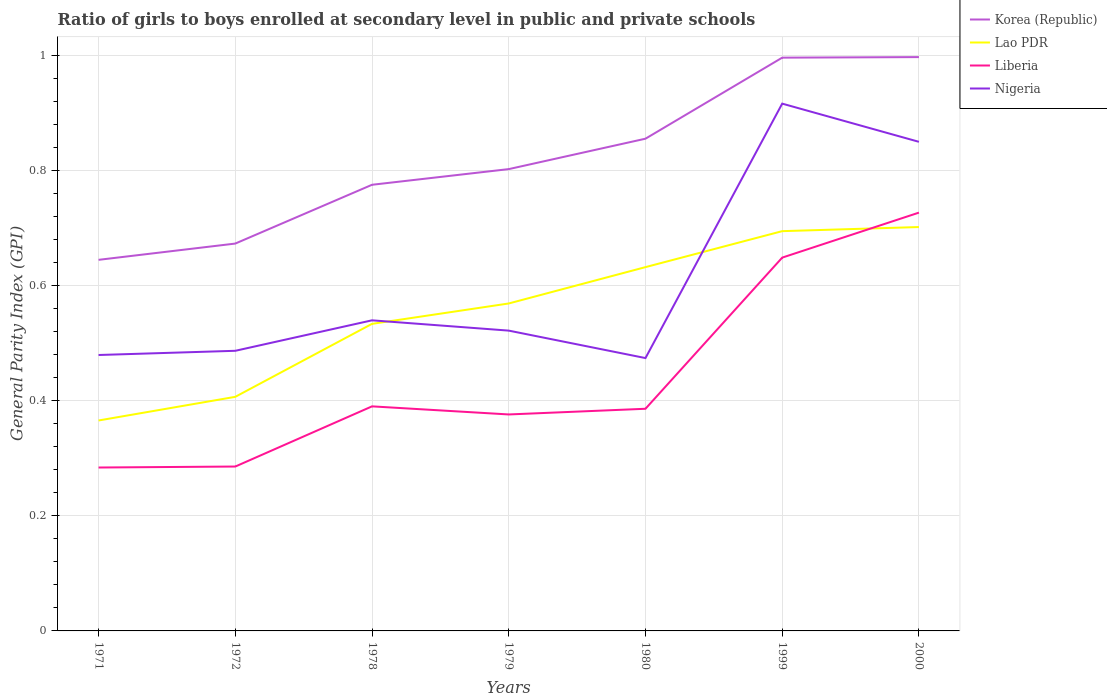How many different coloured lines are there?
Offer a very short reply. 4. Does the line corresponding to Nigeria intersect with the line corresponding to Korea (Republic)?
Provide a succinct answer. No. Across all years, what is the maximum general parity index in Nigeria?
Provide a succinct answer. 0.47. What is the total general parity index in Korea (Republic) in the graph?
Offer a terse response. -0.03. What is the difference between the highest and the second highest general parity index in Nigeria?
Your answer should be very brief. 0.44. Is the general parity index in Nigeria strictly greater than the general parity index in Korea (Republic) over the years?
Provide a succinct answer. Yes. What is the difference between two consecutive major ticks on the Y-axis?
Provide a short and direct response. 0.2. Are the values on the major ticks of Y-axis written in scientific E-notation?
Your answer should be very brief. No. Does the graph contain any zero values?
Offer a very short reply. No. Does the graph contain grids?
Give a very brief answer. Yes. What is the title of the graph?
Keep it short and to the point. Ratio of girls to boys enrolled at secondary level in public and private schools. Does "Turkey" appear as one of the legend labels in the graph?
Your answer should be very brief. No. What is the label or title of the Y-axis?
Offer a terse response. General Parity Index (GPI). What is the General Parity Index (GPI) in Korea (Republic) in 1971?
Make the answer very short. 0.64. What is the General Parity Index (GPI) in Lao PDR in 1971?
Provide a short and direct response. 0.37. What is the General Parity Index (GPI) in Liberia in 1971?
Provide a succinct answer. 0.28. What is the General Parity Index (GPI) of Nigeria in 1971?
Your answer should be very brief. 0.48. What is the General Parity Index (GPI) in Korea (Republic) in 1972?
Give a very brief answer. 0.67. What is the General Parity Index (GPI) in Lao PDR in 1972?
Keep it short and to the point. 0.41. What is the General Parity Index (GPI) of Liberia in 1972?
Provide a short and direct response. 0.29. What is the General Parity Index (GPI) in Nigeria in 1972?
Offer a very short reply. 0.49. What is the General Parity Index (GPI) in Korea (Republic) in 1978?
Provide a short and direct response. 0.77. What is the General Parity Index (GPI) of Lao PDR in 1978?
Your answer should be compact. 0.53. What is the General Parity Index (GPI) of Liberia in 1978?
Keep it short and to the point. 0.39. What is the General Parity Index (GPI) in Nigeria in 1978?
Make the answer very short. 0.54. What is the General Parity Index (GPI) of Korea (Republic) in 1979?
Make the answer very short. 0.8. What is the General Parity Index (GPI) in Lao PDR in 1979?
Your response must be concise. 0.57. What is the General Parity Index (GPI) of Liberia in 1979?
Give a very brief answer. 0.38. What is the General Parity Index (GPI) in Nigeria in 1979?
Give a very brief answer. 0.52. What is the General Parity Index (GPI) in Korea (Republic) in 1980?
Your answer should be compact. 0.86. What is the General Parity Index (GPI) in Lao PDR in 1980?
Give a very brief answer. 0.63. What is the General Parity Index (GPI) in Liberia in 1980?
Your answer should be compact. 0.39. What is the General Parity Index (GPI) in Nigeria in 1980?
Your response must be concise. 0.47. What is the General Parity Index (GPI) in Korea (Republic) in 1999?
Your response must be concise. 1. What is the General Parity Index (GPI) in Lao PDR in 1999?
Ensure brevity in your answer.  0.69. What is the General Parity Index (GPI) in Liberia in 1999?
Your answer should be very brief. 0.65. What is the General Parity Index (GPI) of Nigeria in 1999?
Make the answer very short. 0.92. What is the General Parity Index (GPI) of Korea (Republic) in 2000?
Give a very brief answer. 1. What is the General Parity Index (GPI) in Lao PDR in 2000?
Your answer should be very brief. 0.7. What is the General Parity Index (GPI) in Liberia in 2000?
Your answer should be compact. 0.73. What is the General Parity Index (GPI) of Nigeria in 2000?
Offer a very short reply. 0.85. Across all years, what is the maximum General Parity Index (GPI) of Korea (Republic)?
Ensure brevity in your answer.  1. Across all years, what is the maximum General Parity Index (GPI) in Lao PDR?
Provide a short and direct response. 0.7. Across all years, what is the maximum General Parity Index (GPI) in Liberia?
Your answer should be compact. 0.73. Across all years, what is the maximum General Parity Index (GPI) in Nigeria?
Ensure brevity in your answer.  0.92. Across all years, what is the minimum General Parity Index (GPI) in Korea (Republic)?
Offer a terse response. 0.64. Across all years, what is the minimum General Parity Index (GPI) of Lao PDR?
Ensure brevity in your answer.  0.37. Across all years, what is the minimum General Parity Index (GPI) of Liberia?
Your answer should be compact. 0.28. Across all years, what is the minimum General Parity Index (GPI) in Nigeria?
Your answer should be very brief. 0.47. What is the total General Parity Index (GPI) of Korea (Republic) in the graph?
Make the answer very short. 5.74. What is the total General Parity Index (GPI) in Lao PDR in the graph?
Your response must be concise. 3.9. What is the total General Parity Index (GPI) of Liberia in the graph?
Keep it short and to the point. 3.1. What is the total General Parity Index (GPI) in Nigeria in the graph?
Provide a succinct answer. 4.27. What is the difference between the General Parity Index (GPI) in Korea (Republic) in 1971 and that in 1972?
Your answer should be very brief. -0.03. What is the difference between the General Parity Index (GPI) of Lao PDR in 1971 and that in 1972?
Keep it short and to the point. -0.04. What is the difference between the General Parity Index (GPI) in Liberia in 1971 and that in 1972?
Provide a succinct answer. -0. What is the difference between the General Parity Index (GPI) of Nigeria in 1971 and that in 1972?
Make the answer very short. -0.01. What is the difference between the General Parity Index (GPI) in Korea (Republic) in 1971 and that in 1978?
Ensure brevity in your answer.  -0.13. What is the difference between the General Parity Index (GPI) in Lao PDR in 1971 and that in 1978?
Your answer should be compact. -0.17. What is the difference between the General Parity Index (GPI) in Liberia in 1971 and that in 1978?
Provide a short and direct response. -0.11. What is the difference between the General Parity Index (GPI) of Nigeria in 1971 and that in 1978?
Provide a short and direct response. -0.06. What is the difference between the General Parity Index (GPI) of Korea (Republic) in 1971 and that in 1979?
Your answer should be compact. -0.16. What is the difference between the General Parity Index (GPI) of Lao PDR in 1971 and that in 1979?
Offer a very short reply. -0.2. What is the difference between the General Parity Index (GPI) of Liberia in 1971 and that in 1979?
Ensure brevity in your answer.  -0.09. What is the difference between the General Parity Index (GPI) in Nigeria in 1971 and that in 1979?
Provide a short and direct response. -0.04. What is the difference between the General Parity Index (GPI) of Korea (Republic) in 1971 and that in 1980?
Provide a short and direct response. -0.21. What is the difference between the General Parity Index (GPI) of Lao PDR in 1971 and that in 1980?
Ensure brevity in your answer.  -0.27. What is the difference between the General Parity Index (GPI) in Liberia in 1971 and that in 1980?
Your response must be concise. -0.1. What is the difference between the General Parity Index (GPI) in Nigeria in 1971 and that in 1980?
Ensure brevity in your answer.  0.01. What is the difference between the General Parity Index (GPI) in Korea (Republic) in 1971 and that in 1999?
Provide a short and direct response. -0.35. What is the difference between the General Parity Index (GPI) of Lao PDR in 1971 and that in 1999?
Provide a short and direct response. -0.33. What is the difference between the General Parity Index (GPI) in Liberia in 1971 and that in 1999?
Your answer should be very brief. -0.36. What is the difference between the General Parity Index (GPI) in Nigeria in 1971 and that in 1999?
Give a very brief answer. -0.44. What is the difference between the General Parity Index (GPI) of Korea (Republic) in 1971 and that in 2000?
Give a very brief answer. -0.35. What is the difference between the General Parity Index (GPI) of Lao PDR in 1971 and that in 2000?
Keep it short and to the point. -0.34. What is the difference between the General Parity Index (GPI) in Liberia in 1971 and that in 2000?
Give a very brief answer. -0.44. What is the difference between the General Parity Index (GPI) of Nigeria in 1971 and that in 2000?
Make the answer very short. -0.37. What is the difference between the General Parity Index (GPI) of Korea (Republic) in 1972 and that in 1978?
Keep it short and to the point. -0.1. What is the difference between the General Parity Index (GPI) in Lao PDR in 1972 and that in 1978?
Provide a short and direct response. -0.13. What is the difference between the General Parity Index (GPI) in Liberia in 1972 and that in 1978?
Offer a very short reply. -0.1. What is the difference between the General Parity Index (GPI) in Nigeria in 1972 and that in 1978?
Your answer should be very brief. -0.05. What is the difference between the General Parity Index (GPI) of Korea (Republic) in 1972 and that in 1979?
Your answer should be very brief. -0.13. What is the difference between the General Parity Index (GPI) of Lao PDR in 1972 and that in 1979?
Your response must be concise. -0.16. What is the difference between the General Parity Index (GPI) in Liberia in 1972 and that in 1979?
Offer a very short reply. -0.09. What is the difference between the General Parity Index (GPI) in Nigeria in 1972 and that in 1979?
Your answer should be compact. -0.04. What is the difference between the General Parity Index (GPI) in Korea (Republic) in 1972 and that in 1980?
Provide a succinct answer. -0.18. What is the difference between the General Parity Index (GPI) of Lao PDR in 1972 and that in 1980?
Keep it short and to the point. -0.23. What is the difference between the General Parity Index (GPI) in Liberia in 1972 and that in 1980?
Make the answer very short. -0.1. What is the difference between the General Parity Index (GPI) of Nigeria in 1972 and that in 1980?
Your response must be concise. 0.01. What is the difference between the General Parity Index (GPI) in Korea (Republic) in 1972 and that in 1999?
Your response must be concise. -0.32. What is the difference between the General Parity Index (GPI) of Lao PDR in 1972 and that in 1999?
Keep it short and to the point. -0.29. What is the difference between the General Parity Index (GPI) in Liberia in 1972 and that in 1999?
Keep it short and to the point. -0.36. What is the difference between the General Parity Index (GPI) of Nigeria in 1972 and that in 1999?
Keep it short and to the point. -0.43. What is the difference between the General Parity Index (GPI) in Korea (Republic) in 1972 and that in 2000?
Offer a very short reply. -0.32. What is the difference between the General Parity Index (GPI) in Lao PDR in 1972 and that in 2000?
Provide a succinct answer. -0.29. What is the difference between the General Parity Index (GPI) in Liberia in 1972 and that in 2000?
Offer a terse response. -0.44. What is the difference between the General Parity Index (GPI) in Nigeria in 1972 and that in 2000?
Ensure brevity in your answer.  -0.36. What is the difference between the General Parity Index (GPI) of Korea (Republic) in 1978 and that in 1979?
Your answer should be compact. -0.03. What is the difference between the General Parity Index (GPI) of Lao PDR in 1978 and that in 1979?
Offer a very short reply. -0.04. What is the difference between the General Parity Index (GPI) in Liberia in 1978 and that in 1979?
Your answer should be very brief. 0.01. What is the difference between the General Parity Index (GPI) of Nigeria in 1978 and that in 1979?
Your response must be concise. 0.02. What is the difference between the General Parity Index (GPI) of Korea (Republic) in 1978 and that in 1980?
Provide a short and direct response. -0.08. What is the difference between the General Parity Index (GPI) in Lao PDR in 1978 and that in 1980?
Ensure brevity in your answer.  -0.1. What is the difference between the General Parity Index (GPI) of Liberia in 1978 and that in 1980?
Offer a terse response. 0. What is the difference between the General Parity Index (GPI) of Nigeria in 1978 and that in 1980?
Offer a terse response. 0.07. What is the difference between the General Parity Index (GPI) of Korea (Republic) in 1978 and that in 1999?
Ensure brevity in your answer.  -0.22. What is the difference between the General Parity Index (GPI) of Lao PDR in 1978 and that in 1999?
Provide a succinct answer. -0.16. What is the difference between the General Parity Index (GPI) in Liberia in 1978 and that in 1999?
Make the answer very short. -0.26. What is the difference between the General Parity Index (GPI) of Nigeria in 1978 and that in 1999?
Offer a terse response. -0.38. What is the difference between the General Parity Index (GPI) of Korea (Republic) in 1978 and that in 2000?
Offer a very short reply. -0.22. What is the difference between the General Parity Index (GPI) of Lao PDR in 1978 and that in 2000?
Ensure brevity in your answer.  -0.17. What is the difference between the General Parity Index (GPI) of Liberia in 1978 and that in 2000?
Your answer should be very brief. -0.34. What is the difference between the General Parity Index (GPI) of Nigeria in 1978 and that in 2000?
Provide a succinct answer. -0.31. What is the difference between the General Parity Index (GPI) of Korea (Republic) in 1979 and that in 1980?
Provide a short and direct response. -0.05. What is the difference between the General Parity Index (GPI) of Lao PDR in 1979 and that in 1980?
Your response must be concise. -0.06. What is the difference between the General Parity Index (GPI) in Liberia in 1979 and that in 1980?
Keep it short and to the point. -0.01. What is the difference between the General Parity Index (GPI) of Nigeria in 1979 and that in 1980?
Ensure brevity in your answer.  0.05. What is the difference between the General Parity Index (GPI) in Korea (Republic) in 1979 and that in 1999?
Offer a very short reply. -0.19. What is the difference between the General Parity Index (GPI) of Lao PDR in 1979 and that in 1999?
Give a very brief answer. -0.13. What is the difference between the General Parity Index (GPI) in Liberia in 1979 and that in 1999?
Provide a short and direct response. -0.27. What is the difference between the General Parity Index (GPI) of Nigeria in 1979 and that in 1999?
Give a very brief answer. -0.39. What is the difference between the General Parity Index (GPI) of Korea (Republic) in 1979 and that in 2000?
Keep it short and to the point. -0.19. What is the difference between the General Parity Index (GPI) in Lao PDR in 1979 and that in 2000?
Offer a terse response. -0.13. What is the difference between the General Parity Index (GPI) of Liberia in 1979 and that in 2000?
Your response must be concise. -0.35. What is the difference between the General Parity Index (GPI) of Nigeria in 1979 and that in 2000?
Offer a very short reply. -0.33. What is the difference between the General Parity Index (GPI) of Korea (Republic) in 1980 and that in 1999?
Make the answer very short. -0.14. What is the difference between the General Parity Index (GPI) in Lao PDR in 1980 and that in 1999?
Offer a terse response. -0.06. What is the difference between the General Parity Index (GPI) of Liberia in 1980 and that in 1999?
Keep it short and to the point. -0.26. What is the difference between the General Parity Index (GPI) of Nigeria in 1980 and that in 1999?
Provide a succinct answer. -0.44. What is the difference between the General Parity Index (GPI) in Korea (Republic) in 1980 and that in 2000?
Your answer should be compact. -0.14. What is the difference between the General Parity Index (GPI) in Lao PDR in 1980 and that in 2000?
Keep it short and to the point. -0.07. What is the difference between the General Parity Index (GPI) of Liberia in 1980 and that in 2000?
Your answer should be very brief. -0.34. What is the difference between the General Parity Index (GPI) in Nigeria in 1980 and that in 2000?
Your answer should be compact. -0.38. What is the difference between the General Parity Index (GPI) in Korea (Republic) in 1999 and that in 2000?
Your response must be concise. -0. What is the difference between the General Parity Index (GPI) in Lao PDR in 1999 and that in 2000?
Your response must be concise. -0.01. What is the difference between the General Parity Index (GPI) in Liberia in 1999 and that in 2000?
Keep it short and to the point. -0.08. What is the difference between the General Parity Index (GPI) in Nigeria in 1999 and that in 2000?
Ensure brevity in your answer.  0.07. What is the difference between the General Parity Index (GPI) of Korea (Republic) in 1971 and the General Parity Index (GPI) of Lao PDR in 1972?
Offer a very short reply. 0.24. What is the difference between the General Parity Index (GPI) of Korea (Republic) in 1971 and the General Parity Index (GPI) of Liberia in 1972?
Provide a short and direct response. 0.36. What is the difference between the General Parity Index (GPI) in Korea (Republic) in 1971 and the General Parity Index (GPI) in Nigeria in 1972?
Provide a short and direct response. 0.16. What is the difference between the General Parity Index (GPI) in Lao PDR in 1971 and the General Parity Index (GPI) in Liberia in 1972?
Offer a very short reply. 0.08. What is the difference between the General Parity Index (GPI) in Lao PDR in 1971 and the General Parity Index (GPI) in Nigeria in 1972?
Your answer should be compact. -0.12. What is the difference between the General Parity Index (GPI) of Liberia in 1971 and the General Parity Index (GPI) of Nigeria in 1972?
Provide a short and direct response. -0.2. What is the difference between the General Parity Index (GPI) of Korea (Republic) in 1971 and the General Parity Index (GPI) of Lao PDR in 1978?
Give a very brief answer. 0.11. What is the difference between the General Parity Index (GPI) of Korea (Republic) in 1971 and the General Parity Index (GPI) of Liberia in 1978?
Offer a very short reply. 0.25. What is the difference between the General Parity Index (GPI) of Korea (Republic) in 1971 and the General Parity Index (GPI) of Nigeria in 1978?
Give a very brief answer. 0.11. What is the difference between the General Parity Index (GPI) of Lao PDR in 1971 and the General Parity Index (GPI) of Liberia in 1978?
Your answer should be compact. -0.02. What is the difference between the General Parity Index (GPI) in Lao PDR in 1971 and the General Parity Index (GPI) in Nigeria in 1978?
Provide a short and direct response. -0.17. What is the difference between the General Parity Index (GPI) of Liberia in 1971 and the General Parity Index (GPI) of Nigeria in 1978?
Your answer should be very brief. -0.26. What is the difference between the General Parity Index (GPI) of Korea (Republic) in 1971 and the General Parity Index (GPI) of Lao PDR in 1979?
Make the answer very short. 0.08. What is the difference between the General Parity Index (GPI) in Korea (Republic) in 1971 and the General Parity Index (GPI) in Liberia in 1979?
Ensure brevity in your answer.  0.27. What is the difference between the General Parity Index (GPI) in Korea (Republic) in 1971 and the General Parity Index (GPI) in Nigeria in 1979?
Provide a short and direct response. 0.12. What is the difference between the General Parity Index (GPI) of Lao PDR in 1971 and the General Parity Index (GPI) of Liberia in 1979?
Ensure brevity in your answer.  -0.01. What is the difference between the General Parity Index (GPI) of Lao PDR in 1971 and the General Parity Index (GPI) of Nigeria in 1979?
Offer a terse response. -0.16. What is the difference between the General Parity Index (GPI) in Liberia in 1971 and the General Parity Index (GPI) in Nigeria in 1979?
Your response must be concise. -0.24. What is the difference between the General Parity Index (GPI) of Korea (Republic) in 1971 and the General Parity Index (GPI) of Lao PDR in 1980?
Keep it short and to the point. 0.01. What is the difference between the General Parity Index (GPI) in Korea (Republic) in 1971 and the General Parity Index (GPI) in Liberia in 1980?
Keep it short and to the point. 0.26. What is the difference between the General Parity Index (GPI) in Korea (Republic) in 1971 and the General Parity Index (GPI) in Nigeria in 1980?
Ensure brevity in your answer.  0.17. What is the difference between the General Parity Index (GPI) in Lao PDR in 1971 and the General Parity Index (GPI) in Liberia in 1980?
Give a very brief answer. -0.02. What is the difference between the General Parity Index (GPI) of Lao PDR in 1971 and the General Parity Index (GPI) of Nigeria in 1980?
Give a very brief answer. -0.11. What is the difference between the General Parity Index (GPI) of Liberia in 1971 and the General Parity Index (GPI) of Nigeria in 1980?
Your answer should be compact. -0.19. What is the difference between the General Parity Index (GPI) in Korea (Republic) in 1971 and the General Parity Index (GPI) in Lao PDR in 1999?
Your answer should be very brief. -0.05. What is the difference between the General Parity Index (GPI) of Korea (Republic) in 1971 and the General Parity Index (GPI) of Liberia in 1999?
Your response must be concise. -0. What is the difference between the General Parity Index (GPI) of Korea (Republic) in 1971 and the General Parity Index (GPI) of Nigeria in 1999?
Your answer should be very brief. -0.27. What is the difference between the General Parity Index (GPI) in Lao PDR in 1971 and the General Parity Index (GPI) in Liberia in 1999?
Keep it short and to the point. -0.28. What is the difference between the General Parity Index (GPI) in Lao PDR in 1971 and the General Parity Index (GPI) in Nigeria in 1999?
Ensure brevity in your answer.  -0.55. What is the difference between the General Parity Index (GPI) in Liberia in 1971 and the General Parity Index (GPI) in Nigeria in 1999?
Provide a succinct answer. -0.63. What is the difference between the General Parity Index (GPI) in Korea (Republic) in 1971 and the General Parity Index (GPI) in Lao PDR in 2000?
Give a very brief answer. -0.06. What is the difference between the General Parity Index (GPI) of Korea (Republic) in 1971 and the General Parity Index (GPI) of Liberia in 2000?
Ensure brevity in your answer.  -0.08. What is the difference between the General Parity Index (GPI) of Korea (Republic) in 1971 and the General Parity Index (GPI) of Nigeria in 2000?
Ensure brevity in your answer.  -0.2. What is the difference between the General Parity Index (GPI) of Lao PDR in 1971 and the General Parity Index (GPI) of Liberia in 2000?
Make the answer very short. -0.36. What is the difference between the General Parity Index (GPI) in Lao PDR in 1971 and the General Parity Index (GPI) in Nigeria in 2000?
Offer a very short reply. -0.48. What is the difference between the General Parity Index (GPI) of Liberia in 1971 and the General Parity Index (GPI) of Nigeria in 2000?
Your answer should be very brief. -0.57. What is the difference between the General Parity Index (GPI) of Korea (Republic) in 1972 and the General Parity Index (GPI) of Lao PDR in 1978?
Your answer should be compact. 0.14. What is the difference between the General Parity Index (GPI) in Korea (Republic) in 1972 and the General Parity Index (GPI) in Liberia in 1978?
Provide a succinct answer. 0.28. What is the difference between the General Parity Index (GPI) in Korea (Republic) in 1972 and the General Parity Index (GPI) in Nigeria in 1978?
Offer a terse response. 0.13. What is the difference between the General Parity Index (GPI) of Lao PDR in 1972 and the General Parity Index (GPI) of Liberia in 1978?
Give a very brief answer. 0.02. What is the difference between the General Parity Index (GPI) of Lao PDR in 1972 and the General Parity Index (GPI) of Nigeria in 1978?
Your answer should be very brief. -0.13. What is the difference between the General Parity Index (GPI) in Liberia in 1972 and the General Parity Index (GPI) in Nigeria in 1978?
Offer a terse response. -0.25. What is the difference between the General Parity Index (GPI) in Korea (Republic) in 1972 and the General Parity Index (GPI) in Lao PDR in 1979?
Keep it short and to the point. 0.1. What is the difference between the General Parity Index (GPI) of Korea (Republic) in 1972 and the General Parity Index (GPI) of Liberia in 1979?
Your response must be concise. 0.3. What is the difference between the General Parity Index (GPI) of Korea (Republic) in 1972 and the General Parity Index (GPI) of Nigeria in 1979?
Your answer should be very brief. 0.15. What is the difference between the General Parity Index (GPI) of Lao PDR in 1972 and the General Parity Index (GPI) of Liberia in 1979?
Your response must be concise. 0.03. What is the difference between the General Parity Index (GPI) of Lao PDR in 1972 and the General Parity Index (GPI) of Nigeria in 1979?
Ensure brevity in your answer.  -0.12. What is the difference between the General Parity Index (GPI) in Liberia in 1972 and the General Parity Index (GPI) in Nigeria in 1979?
Your answer should be compact. -0.24. What is the difference between the General Parity Index (GPI) of Korea (Republic) in 1972 and the General Parity Index (GPI) of Lao PDR in 1980?
Offer a terse response. 0.04. What is the difference between the General Parity Index (GPI) in Korea (Republic) in 1972 and the General Parity Index (GPI) in Liberia in 1980?
Give a very brief answer. 0.29. What is the difference between the General Parity Index (GPI) in Korea (Republic) in 1972 and the General Parity Index (GPI) in Nigeria in 1980?
Provide a succinct answer. 0.2. What is the difference between the General Parity Index (GPI) in Lao PDR in 1972 and the General Parity Index (GPI) in Liberia in 1980?
Give a very brief answer. 0.02. What is the difference between the General Parity Index (GPI) in Lao PDR in 1972 and the General Parity Index (GPI) in Nigeria in 1980?
Offer a terse response. -0.07. What is the difference between the General Parity Index (GPI) in Liberia in 1972 and the General Parity Index (GPI) in Nigeria in 1980?
Provide a succinct answer. -0.19. What is the difference between the General Parity Index (GPI) in Korea (Republic) in 1972 and the General Parity Index (GPI) in Lao PDR in 1999?
Give a very brief answer. -0.02. What is the difference between the General Parity Index (GPI) of Korea (Republic) in 1972 and the General Parity Index (GPI) of Liberia in 1999?
Give a very brief answer. 0.02. What is the difference between the General Parity Index (GPI) of Korea (Republic) in 1972 and the General Parity Index (GPI) of Nigeria in 1999?
Ensure brevity in your answer.  -0.24. What is the difference between the General Parity Index (GPI) of Lao PDR in 1972 and the General Parity Index (GPI) of Liberia in 1999?
Your response must be concise. -0.24. What is the difference between the General Parity Index (GPI) in Lao PDR in 1972 and the General Parity Index (GPI) in Nigeria in 1999?
Your response must be concise. -0.51. What is the difference between the General Parity Index (GPI) of Liberia in 1972 and the General Parity Index (GPI) of Nigeria in 1999?
Offer a terse response. -0.63. What is the difference between the General Parity Index (GPI) in Korea (Republic) in 1972 and the General Parity Index (GPI) in Lao PDR in 2000?
Make the answer very short. -0.03. What is the difference between the General Parity Index (GPI) of Korea (Republic) in 1972 and the General Parity Index (GPI) of Liberia in 2000?
Your response must be concise. -0.05. What is the difference between the General Parity Index (GPI) of Korea (Republic) in 1972 and the General Parity Index (GPI) of Nigeria in 2000?
Offer a very short reply. -0.18. What is the difference between the General Parity Index (GPI) in Lao PDR in 1972 and the General Parity Index (GPI) in Liberia in 2000?
Provide a short and direct response. -0.32. What is the difference between the General Parity Index (GPI) of Lao PDR in 1972 and the General Parity Index (GPI) of Nigeria in 2000?
Provide a succinct answer. -0.44. What is the difference between the General Parity Index (GPI) of Liberia in 1972 and the General Parity Index (GPI) of Nigeria in 2000?
Your answer should be very brief. -0.56. What is the difference between the General Parity Index (GPI) of Korea (Republic) in 1978 and the General Parity Index (GPI) of Lao PDR in 1979?
Keep it short and to the point. 0.21. What is the difference between the General Parity Index (GPI) in Korea (Republic) in 1978 and the General Parity Index (GPI) in Liberia in 1979?
Keep it short and to the point. 0.4. What is the difference between the General Parity Index (GPI) of Korea (Republic) in 1978 and the General Parity Index (GPI) of Nigeria in 1979?
Your response must be concise. 0.25. What is the difference between the General Parity Index (GPI) of Lao PDR in 1978 and the General Parity Index (GPI) of Liberia in 1979?
Provide a succinct answer. 0.16. What is the difference between the General Parity Index (GPI) in Lao PDR in 1978 and the General Parity Index (GPI) in Nigeria in 1979?
Give a very brief answer. 0.01. What is the difference between the General Parity Index (GPI) of Liberia in 1978 and the General Parity Index (GPI) of Nigeria in 1979?
Provide a succinct answer. -0.13. What is the difference between the General Parity Index (GPI) of Korea (Republic) in 1978 and the General Parity Index (GPI) of Lao PDR in 1980?
Your answer should be compact. 0.14. What is the difference between the General Parity Index (GPI) of Korea (Republic) in 1978 and the General Parity Index (GPI) of Liberia in 1980?
Your answer should be very brief. 0.39. What is the difference between the General Parity Index (GPI) in Korea (Republic) in 1978 and the General Parity Index (GPI) in Nigeria in 1980?
Offer a terse response. 0.3. What is the difference between the General Parity Index (GPI) in Lao PDR in 1978 and the General Parity Index (GPI) in Liberia in 1980?
Your response must be concise. 0.15. What is the difference between the General Parity Index (GPI) in Lao PDR in 1978 and the General Parity Index (GPI) in Nigeria in 1980?
Offer a terse response. 0.06. What is the difference between the General Parity Index (GPI) in Liberia in 1978 and the General Parity Index (GPI) in Nigeria in 1980?
Give a very brief answer. -0.08. What is the difference between the General Parity Index (GPI) in Korea (Republic) in 1978 and the General Parity Index (GPI) in Lao PDR in 1999?
Offer a very short reply. 0.08. What is the difference between the General Parity Index (GPI) of Korea (Republic) in 1978 and the General Parity Index (GPI) of Liberia in 1999?
Provide a succinct answer. 0.13. What is the difference between the General Parity Index (GPI) of Korea (Republic) in 1978 and the General Parity Index (GPI) of Nigeria in 1999?
Your response must be concise. -0.14. What is the difference between the General Parity Index (GPI) of Lao PDR in 1978 and the General Parity Index (GPI) of Liberia in 1999?
Your answer should be very brief. -0.12. What is the difference between the General Parity Index (GPI) of Lao PDR in 1978 and the General Parity Index (GPI) of Nigeria in 1999?
Your answer should be compact. -0.38. What is the difference between the General Parity Index (GPI) of Liberia in 1978 and the General Parity Index (GPI) of Nigeria in 1999?
Your answer should be compact. -0.53. What is the difference between the General Parity Index (GPI) of Korea (Republic) in 1978 and the General Parity Index (GPI) of Lao PDR in 2000?
Offer a very short reply. 0.07. What is the difference between the General Parity Index (GPI) in Korea (Republic) in 1978 and the General Parity Index (GPI) in Liberia in 2000?
Your response must be concise. 0.05. What is the difference between the General Parity Index (GPI) in Korea (Republic) in 1978 and the General Parity Index (GPI) in Nigeria in 2000?
Make the answer very short. -0.07. What is the difference between the General Parity Index (GPI) in Lao PDR in 1978 and the General Parity Index (GPI) in Liberia in 2000?
Offer a terse response. -0.19. What is the difference between the General Parity Index (GPI) in Lao PDR in 1978 and the General Parity Index (GPI) in Nigeria in 2000?
Make the answer very short. -0.32. What is the difference between the General Parity Index (GPI) in Liberia in 1978 and the General Parity Index (GPI) in Nigeria in 2000?
Give a very brief answer. -0.46. What is the difference between the General Parity Index (GPI) in Korea (Republic) in 1979 and the General Parity Index (GPI) in Lao PDR in 1980?
Your response must be concise. 0.17. What is the difference between the General Parity Index (GPI) in Korea (Republic) in 1979 and the General Parity Index (GPI) in Liberia in 1980?
Make the answer very short. 0.42. What is the difference between the General Parity Index (GPI) of Korea (Republic) in 1979 and the General Parity Index (GPI) of Nigeria in 1980?
Ensure brevity in your answer.  0.33. What is the difference between the General Parity Index (GPI) of Lao PDR in 1979 and the General Parity Index (GPI) of Liberia in 1980?
Your answer should be very brief. 0.18. What is the difference between the General Parity Index (GPI) of Lao PDR in 1979 and the General Parity Index (GPI) of Nigeria in 1980?
Provide a succinct answer. 0.09. What is the difference between the General Parity Index (GPI) in Liberia in 1979 and the General Parity Index (GPI) in Nigeria in 1980?
Offer a very short reply. -0.1. What is the difference between the General Parity Index (GPI) in Korea (Republic) in 1979 and the General Parity Index (GPI) in Lao PDR in 1999?
Your answer should be very brief. 0.11. What is the difference between the General Parity Index (GPI) in Korea (Republic) in 1979 and the General Parity Index (GPI) in Liberia in 1999?
Give a very brief answer. 0.15. What is the difference between the General Parity Index (GPI) of Korea (Republic) in 1979 and the General Parity Index (GPI) of Nigeria in 1999?
Make the answer very short. -0.11. What is the difference between the General Parity Index (GPI) in Lao PDR in 1979 and the General Parity Index (GPI) in Liberia in 1999?
Provide a short and direct response. -0.08. What is the difference between the General Parity Index (GPI) in Lao PDR in 1979 and the General Parity Index (GPI) in Nigeria in 1999?
Make the answer very short. -0.35. What is the difference between the General Parity Index (GPI) in Liberia in 1979 and the General Parity Index (GPI) in Nigeria in 1999?
Your answer should be very brief. -0.54. What is the difference between the General Parity Index (GPI) of Korea (Republic) in 1979 and the General Parity Index (GPI) of Lao PDR in 2000?
Your answer should be very brief. 0.1. What is the difference between the General Parity Index (GPI) in Korea (Republic) in 1979 and the General Parity Index (GPI) in Liberia in 2000?
Make the answer very short. 0.08. What is the difference between the General Parity Index (GPI) of Korea (Republic) in 1979 and the General Parity Index (GPI) of Nigeria in 2000?
Your answer should be compact. -0.05. What is the difference between the General Parity Index (GPI) of Lao PDR in 1979 and the General Parity Index (GPI) of Liberia in 2000?
Your answer should be very brief. -0.16. What is the difference between the General Parity Index (GPI) of Lao PDR in 1979 and the General Parity Index (GPI) of Nigeria in 2000?
Offer a very short reply. -0.28. What is the difference between the General Parity Index (GPI) of Liberia in 1979 and the General Parity Index (GPI) of Nigeria in 2000?
Your answer should be compact. -0.47. What is the difference between the General Parity Index (GPI) in Korea (Republic) in 1980 and the General Parity Index (GPI) in Lao PDR in 1999?
Provide a short and direct response. 0.16. What is the difference between the General Parity Index (GPI) of Korea (Republic) in 1980 and the General Parity Index (GPI) of Liberia in 1999?
Offer a terse response. 0.21. What is the difference between the General Parity Index (GPI) in Korea (Republic) in 1980 and the General Parity Index (GPI) in Nigeria in 1999?
Your response must be concise. -0.06. What is the difference between the General Parity Index (GPI) of Lao PDR in 1980 and the General Parity Index (GPI) of Liberia in 1999?
Keep it short and to the point. -0.02. What is the difference between the General Parity Index (GPI) in Lao PDR in 1980 and the General Parity Index (GPI) in Nigeria in 1999?
Keep it short and to the point. -0.28. What is the difference between the General Parity Index (GPI) of Liberia in 1980 and the General Parity Index (GPI) of Nigeria in 1999?
Ensure brevity in your answer.  -0.53. What is the difference between the General Parity Index (GPI) in Korea (Republic) in 1980 and the General Parity Index (GPI) in Lao PDR in 2000?
Ensure brevity in your answer.  0.15. What is the difference between the General Parity Index (GPI) of Korea (Republic) in 1980 and the General Parity Index (GPI) of Liberia in 2000?
Give a very brief answer. 0.13. What is the difference between the General Parity Index (GPI) in Korea (Republic) in 1980 and the General Parity Index (GPI) in Nigeria in 2000?
Give a very brief answer. 0.01. What is the difference between the General Parity Index (GPI) in Lao PDR in 1980 and the General Parity Index (GPI) in Liberia in 2000?
Make the answer very short. -0.09. What is the difference between the General Parity Index (GPI) in Lao PDR in 1980 and the General Parity Index (GPI) in Nigeria in 2000?
Your response must be concise. -0.22. What is the difference between the General Parity Index (GPI) in Liberia in 1980 and the General Parity Index (GPI) in Nigeria in 2000?
Offer a terse response. -0.46. What is the difference between the General Parity Index (GPI) in Korea (Republic) in 1999 and the General Parity Index (GPI) in Lao PDR in 2000?
Provide a short and direct response. 0.29. What is the difference between the General Parity Index (GPI) of Korea (Republic) in 1999 and the General Parity Index (GPI) of Liberia in 2000?
Your answer should be compact. 0.27. What is the difference between the General Parity Index (GPI) in Korea (Republic) in 1999 and the General Parity Index (GPI) in Nigeria in 2000?
Offer a very short reply. 0.15. What is the difference between the General Parity Index (GPI) of Lao PDR in 1999 and the General Parity Index (GPI) of Liberia in 2000?
Keep it short and to the point. -0.03. What is the difference between the General Parity Index (GPI) in Lao PDR in 1999 and the General Parity Index (GPI) in Nigeria in 2000?
Your response must be concise. -0.16. What is the difference between the General Parity Index (GPI) in Liberia in 1999 and the General Parity Index (GPI) in Nigeria in 2000?
Offer a very short reply. -0.2. What is the average General Parity Index (GPI) in Korea (Republic) per year?
Your response must be concise. 0.82. What is the average General Parity Index (GPI) in Lao PDR per year?
Your response must be concise. 0.56. What is the average General Parity Index (GPI) of Liberia per year?
Your answer should be very brief. 0.44. What is the average General Parity Index (GPI) of Nigeria per year?
Give a very brief answer. 0.61. In the year 1971, what is the difference between the General Parity Index (GPI) in Korea (Republic) and General Parity Index (GPI) in Lao PDR?
Ensure brevity in your answer.  0.28. In the year 1971, what is the difference between the General Parity Index (GPI) in Korea (Republic) and General Parity Index (GPI) in Liberia?
Provide a short and direct response. 0.36. In the year 1971, what is the difference between the General Parity Index (GPI) of Korea (Republic) and General Parity Index (GPI) of Nigeria?
Provide a succinct answer. 0.17. In the year 1971, what is the difference between the General Parity Index (GPI) of Lao PDR and General Parity Index (GPI) of Liberia?
Offer a terse response. 0.08. In the year 1971, what is the difference between the General Parity Index (GPI) of Lao PDR and General Parity Index (GPI) of Nigeria?
Offer a very short reply. -0.11. In the year 1971, what is the difference between the General Parity Index (GPI) of Liberia and General Parity Index (GPI) of Nigeria?
Offer a very short reply. -0.2. In the year 1972, what is the difference between the General Parity Index (GPI) in Korea (Republic) and General Parity Index (GPI) in Lao PDR?
Keep it short and to the point. 0.27. In the year 1972, what is the difference between the General Parity Index (GPI) of Korea (Republic) and General Parity Index (GPI) of Liberia?
Give a very brief answer. 0.39. In the year 1972, what is the difference between the General Parity Index (GPI) in Korea (Republic) and General Parity Index (GPI) in Nigeria?
Make the answer very short. 0.19. In the year 1972, what is the difference between the General Parity Index (GPI) of Lao PDR and General Parity Index (GPI) of Liberia?
Offer a terse response. 0.12. In the year 1972, what is the difference between the General Parity Index (GPI) of Lao PDR and General Parity Index (GPI) of Nigeria?
Keep it short and to the point. -0.08. In the year 1972, what is the difference between the General Parity Index (GPI) in Liberia and General Parity Index (GPI) in Nigeria?
Your answer should be compact. -0.2. In the year 1978, what is the difference between the General Parity Index (GPI) of Korea (Republic) and General Parity Index (GPI) of Lao PDR?
Your answer should be compact. 0.24. In the year 1978, what is the difference between the General Parity Index (GPI) of Korea (Republic) and General Parity Index (GPI) of Liberia?
Offer a terse response. 0.38. In the year 1978, what is the difference between the General Parity Index (GPI) in Korea (Republic) and General Parity Index (GPI) in Nigeria?
Provide a succinct answer. 0.24. In the year 1978, what is the difference between the General Parity Index (GPI) of Lao PDR and General Parity Index (GPI) of Liberia?
Your answer should be very brief. 0.14. In the year 1978, what is the difference between the General Parity Index (GPI) in Lao PDR and General Parity Index (GPI) in Nigeria?
Your answer should be compact. -0.01. In the year 1978, what is the difference between the General Parity Index (GPI) of Liberia and General Parity Index (GPI) of Nigeria?
Make the answer very short. -0.15. In the year 1979, what is the difference between the General Parity Index (GPI) in Korea (Republic) and General Parity Index (GPI) in Lao PDR?
Keep it short and to the point. 0.23. In the year 1979, what is the difference between the General Parity Index (GPI) of Korea (Republic) and General Parity Index (GPI) of Liberia?
Provide a succinct answer. 0.43. In the year 1979, what is the difference between the General Parity Index (GPI) of Korea (Republic) and General Parity Index (GPI) of Nigeria?
Provide a short and direct response. 0.28. In the year 1979, what is the difference between the General Parity Index (GPI) of Lao PDR and General Parity Index (GPI) of Liberia?
Offer a terse response. 0.19. In the year 1979, what is the difference between the General Parity Index (GPI) in Lao PDR and General Parity Index (GPI) in Nigeria?
Give a very brief answer. 0.05. In the year 1979, what is the difference between the General Parity Index (GPI) in Liberia and General Parity Index (GPI) in Nigeria?
Ensure brevity in your answer.  -0.15. In the year 1980, what is the difference between the General Parity Index (GPI) in Korea (Republic) and General Parity Index (GPI) in Lao PDR?
Provide a short and direct response. 0.22. In the year 1980, what is the difference between the General Parity Index (GPI) in Korea (Republic) and General Parity Index (GPI) in Liberia?
Offer a terse response. 0.47. In the year 1980, what is the difference between the General Parity Index (GPI) in Korea (Republic) and General Parity Index (GPI) in Nigeria?
Your response must be concise. 0.38. In the year 1980, what is the difference between the General Parity Index (GPI) in Lao PDR and General Parity Index (GPI) in Liberia?
Your response must be concise. 0.25. In the year 1980, what is the difference between the General Parity Index (GPI) of Lao PDR and General Parity Index (GPI) of Nigeria?
Your answer should be very brief. 0.16. In the year 1980, what is the difference between the General Parity Index (GPI) in Liberia and General Parity Index (GPI) in Nigeria?
Your answer should be compact. -0.09. In the year 1999, what is the difference between the General Parity Index (GPI) of Korea (Republic) and General Parity Index (GPI) of Lao PDR?
Your answer should be compact. 0.3. In the year 1999, what is the difference between the General Parity Index (GPI) of Korea (Republic) and General Parity Index (GPI) of Liberia?
Your answer should be compact. 0.35. In the year 1999, what is the difference between the General Parity Index (GPI) in Korea (Republic) and General Parity Index (GPI) in Nigeria?
Provide a succinct answer. 0.08. In the year 1999, what is the difference between the General Parity Index (GPI) in Lao PDR and General Parity Index (GPI) in Liberia?
Ensure brevity in your answer.  0.05. In the year 1999, what is the difference between the General Parity Index (GPI) of Lao PDR and General Parity Index (GPI) of Nigeria?
Make the answer very short. -0.22. In the year 1999, what is the difference between the General Parity Index (GPI) in Liberia and General Parity Index (GPI) in Nigeria?
Your answer should be very brief. -0.27. In the year 2000, what is the difference between the General Parity Index (GPI) in Korea (Republic) and General Parity Index (GPI) in Lao PDR?
Your answer should be compact. 0.3. In the year 2000, what is the difference between the General Parity Index (GPI) in Korea (Republic) and General Parity Index (GPI) in Liberia?
Offer a terse response. 0.27. In the year 2000, what is the difference between the General Parity Index (GPI) of Korea (Republic) and General Parity Index (GPI) of Nigeria?
Give a very brief answer. 0.15. In the year 2000, what is the difference between the General Parity Index (GPI) in Lao PDR and General Parity Index (GPI) in Liberia?
Offer a terse response. -0.03. In the year 2000, what is the difference between the General Parity Index (GPI) of Lao PDR and General Parity Index (GPI) of Nigeria?
Provide a succinct answer. -0.15. In the year 2000, what is the difference between the General Parity Index (GPI) in Liberia and General Parity Index (GPI) in Nigeria?
Make the answer very short. -0.12. What is the ratio of the General Parity Index (GPI) of Korea (Republic) in 1971 to that in 1972?
Your answer should be compact. 0.96. What is the ratio of the General Parity Index (GPI) in Lao PDR in 1971 to that in 1972?
Make the answer very short. 0.9. What is the ratio of the General Parity Index (GPI) of Nigeria in 1971 to that in 1972?
Offer a terse response. 0.98. What is the ratio of the General Parity Index (GPI) of Korea (Republic) in 1971 to that in 1978?
Offer a terse response. 0.83. What is the ratio of the General Parity Index (GPI) of Lao PDR in 1971 to that in 1978?
Offer a terse response. 0.69. What is the ratio of the General Parity Index (GPI) of Liberia in 1971 to that in 1978?
Provide a short and direct response. 0.73. What is the ratio of the General Parity Index (GPI) in Nigeria in 1971 to that in 1978?
Your answer should be compact. 0.89. What is the ratio of the General Parity Index (GPI) in Korea (Republic) in 1971 to that in 1979?
Provide a succinct answer. 0.8. What is the ratio of the General Parity Index (GPI) of Lao PDR in 1971 to that in 1979?
Make the answer very short. 0.64. What is the ratio of the General Parity Index (GPI) in Liberia in 1971 to that in 1979?
Offer a terse response. 0.75. What is the ratio of the General Parity Index (GPI) in Nigeria in 1971 to that in 1979?
Provide a succinct answer. 0.92. What is the ratio of the General Parity Index (GPI) of Korea (Republic) in 1971 to that in 1980?
Provide a short and direct response. 0.75. What is the ratio of the General Parity Index (GPI) in Lao PDR in 1971 to that in 1980?
Offer a very short reply. 0.58. What is the ratio of the General Parity Index (GPI) of Liberia in 1971 to that in 1980?
Your response must be concise. 0.74. What is the ratio of the General Parity Index (GPI) in Nigeria in 1971 to that in 1980?
Offer a terse response. 1.01. What is the ratio of the General Parity Index (GPI) of Korea (Republic) in 1971 to that in 1999?
Give a very brief answer. 0.65. What is the ratio of the General Parity Index (GPI) in Lao PDR in 1971 to that in 1999?
Ensure brevity in your answer.  0.53. What is the ratio of the General Parity Index (GPI) of Liberia in 1971 to that in 1999?
Your response must be concise. 0.44. What is the ratio of the General Parity Index (GPI) in Nigeria in 1971 to that in 1999?
Your response must be concise. 0.52. What is the ratio of the General Parity Index (GPI) in Korea (Republic) in 1971 to that in 2000?
Make the answer very short. 0.65. What is the ratio of the General Parity Index (GPI) of Lao PDR in 1971 to that in 2000?
Offer a very short reply. 0.52. What is the ratio of the General Parity Index (GPI) in Liberia in 1971 to that in 2000?
Offer a terse response. 0.39. What is the ratio of the General Parity Index (GPI) of Nigeria in 1971 to that in 2000?
Ensure brevity in your answer.  0.56. What is the ratio of the General Parity Index (GPI) of Korea (Republic) in 1972 to that in 1978?
Make the answer very short. 0.87. What is the ratio of the General Parity Index (GPI) of Lao PDR in 1972 to that in 1978?
Ensure brevity in your answer.  0.76. What is the ratio of the General Parity Index (GPI) of Liberia in 1972 to that in 1978?
Keep it short and to the point. 0.73. What is the ratio of the General Parity Index (GPI) in Nigeria in 1972 to that in 1978?
Make the answer very short. 0.9. What is the ratio of the General Parity Index (GPI) of Korea (Republic) in 1972 to that in 1979?
Offer a terse response. 0.84. What is the ratio of the General Parity Index (GPI) of Lao PDR in 1972 to that in 1979?
Provide a succinct answer. 0.71. What is the ratio of the General Parity Index (GPI) of Liberia in 1972 to that in 1979?
Provide a short and direct response. 0.76. What is the ratio of the General Parity Index (GPI) in Nigeria in 1972 to that in 1979?
Keep it short and to the point. 0.93. What is the ratio of the General Parity Index (GPI) of Korea (Republic) in 1972 to that in 1980?
Your response must be concise. 0.79. What is the ratio of the General Parity Index (GPI) of Lao PDR in 1972 to that in 1980?
Provide a succinct answer. 0.64. What is the ratio of the General Parity Index (GPI) of Liberia in 1972 to that in 1980?
Your response must be concise. 0.74. What is the ratio of the General Parity Index (GPI) in Nigeria in 1972 to that in 1980?
Give a very brief answer. 1.03. What is the ratio of the General Parity Index (GPI) of Korea (Republic) in 1972 to that in 1999?
Your answer should be very brief. 0.68. What is the ratio of the General Parity Index (GPI) in Lao PDR in 1972 to that in 1999?
Provide a short and direct response. 0.59. What is the ratio of the General Parity Index (GPI) in Liberia in 1972 to that in 1999?
Offer a terse response. 0.44. What is the ratio of the General Parity Index (GPI) in Nigeria in 1972 to that in 1999?
Ensure brevity in your answer.  0.53. What is the ratio of the General Parity Index (GPI) of Korea (Republic) in 1972 to that in 2000?
Offer a very short reply. 0.68. What is the ratio of the General Parity Index (GPI) in Lao PDR in 1972 to that in 2000?
Offer a terse response. 0.58. What is the ratio of the General Parity Index (GPI) in Liberia in 1972 to that in 2000?
Keep it short and to the point. 0.39. What is the ratio of the General Parity Index (GPI) of Nigeria in 1972 to that in 2000?
Your response must be concise. 0.57. What is the ratio of the General Parity Index (GPI) of Korea (Republic) in 1978 to that in 1979?
Your answer should be compact. 0.97. What is the ratio of the General Parity Index (GPI) in Lao PDR in 1978 to that in 1979?
Keep it short and to the point. 0.94. What is the ratio of the General Parity Index (GPI) of Liberia in 1978 to that in 1979?
Keep it short and to the point. 1.04. What is the ratio of the General Parity Index (GPI) in Nigeria in 1978 to that in 1979?
Provide a succinct answer. 1.03. What is the ratio of the General Parity Index (GPI) in Korea (Republic) in 1978 to that in 1980?
Make the answer very short. 0.91. What is the ratio of the General Parity Index (GPI) in Lao PDR in 1978 to that in 1980?
Offer a terse response. 0.84. What is the ratio of the General Parity Index (GPI) in Liberia in 1978 to that in 1980?
Make the answer very short. 1.01. What is the ratio of the General Parity Index (GPI) of Nigeria in 1978 to that in 1980?
Your response must be concise. 1.14. What is the ratio of the General Parity Index (GPI) in Korea (Republic) in 1978 to that in 1999?
Make the answer very short. 0.78. What is the ratio of the General Parity Index (GPI) in Lao PDR in 1978 to that in 1999?
Keep it short and to the point. 0.77. What is the ratio of the General Parity Index (GPI) of Liberia in 1978 to that in 1999?
Offer a terse response. 0.6. What is the ratio of the General Parity Index (GPI) in Nigeria in 1978 to that in 1999?
Offer a very short reply. 0.59. What is the ratio of the General Parity Index (GPI) in Korea (Republic) in 1978 to that in 2000?
Ensure brevity in your answer.  0.78. What is the ratio of the General Parity Index (GPI) in Lao PDR in 1978 to that in 2000?
Provide a short and direct response. 0.76. What is the ratio of the General Parity Index (GPI) of Liberia in 1978 to that in 2000?
Your answer should be compact. 0.54. What is the ratio of the General Parity Index (GPI) of Nigeria in 1978 to that in 2000?
Your response must be concise. 0.64. What is the ratio of the General Parity Index (GPI) in Korea (Republic) in 1979 to that in 1980?
Your answer should be very brief. 0.94. What is the ratio of the General Parity Index (GPI) of Lao PDR in 1979 to that in 1980?
Your answer should be very brief. 0.9. What is the ratio of the General Parity Index (GPI) in Liberia in 1979 to that in 1980?
Ensure brevity in your answer.  0.97. What is the ratio of the General Parity Index (GPI) in Nigeria in 1979 to that in 1980?
Provide a short and direct response. 1.1. What is the ratio of the General Parity Index (GPI) in Korea (Republic) in 1979 to that in 1999?
Your answer should be very brief. 0.81. What is the ratio of the General Parity Index (GPI) in Lao PDR in 1979 to that in 1999?
Keep it short and to the point. 0.82. What is the ratio of the General Parity Index (GPI) of Liberia in 1979 to that in 1999?
Give a very brief answer. 0.58. What is the ratio of the General Parity Index (GPI) of Nigeria in 1979 to that in 1999?
Make the answer very short. 0.57. What is the ratio of the General Parity Index (GPI) of Korea (Republic) in 1979 to that in 2000?
Provide a short and direct response. 0.8. What is the ratio of the General Parity Index (GPI) in Lao PDR in 1979 to that in 2000?
Provide a succinct answer. 0.81. What is the ratio of the General Parity Index (GPI) in Liberia in 1979 to that in 2000?
Give a very brief answer. 0.52. What is the ratio of the General Parity Index (GPI) in Nigeria in 1979 to that in 2000?
Give a very brief answer. 0.61. What is the ratio of the General Parity Index (GPI) in Korea (Republic) in 1980 to that in 1999?
Your answer should be compact. 0.86. What is the ratio of the General Parity Index (GPI) in Lao PDR in 1980 to that in 1999?
Offer a terse response. 0.91. What is the ratio of the General Parity Index (GPI) in Liberia in 1980 to that in 1999?
Keep it short and to the point. 0.6. What is the ratio of the General Parity Index (GPI) in Nigeria in 1980 to that in 1999?
Your response must be concise. 0.52. What is the ratio of the General Parity Index (GPI) in Korea (Republic) in 1980 to that in 2000?
Make the answer very short. 0.86. What is the ratio of the General Parity Index (GPI) in Lao PDR in 1980 to that in 2000?
Give a very brief answer. 0.9. What is the ratio of the General Parity Index (GPI) of Liberia in 1980 to that in 2000?
Ensure brevity in your answer.  0.53. What is the ratio of the General Parity Index (GPI) of Nigeria in 1980 to that in 2000?
Your answer should be very brief. 0.56. What is the ratio of the General Parity Index (GPI) in Lao PDR in 1999 to that in 2000?
Provide a succinct answer. 0.99. What is the ratio of the General Parity Index (GPI) of Liberia in 1999 to that in 2000?
Provide a short and direct response. 0.89. What is the ratio of the General Parity Index (GPI) of Nigeria in 1999 to that in 2000?
Offer a very short reply. 1.08. What is the difference between the highest and the second highest General Parity Index (GPI) of Korea (Republic)?
Give a very brief answer. 0. What is the difference between the highest and the second highest General Parity Index (GPI) of Lao PDR?
Provide a short and direct response. 0.01. What is the difference between the highest and the second highest General Parity Index (GPI) of Liberia?
Offer a terse response. 0.08. What is the difference between the highest and the second highest General Parity Index (GPI) of Nigeria?
Provide a succinct answer. 0.07. What is the difference between the highest and the lowest General Parity Index (GPI) of Korea (Republic)?
Your response must be concise. 0.35. What is the difference between the highest and the lowest General Parity Index (GPI) of Lao PDR?
Provide a short and direct response. 0.34. What is the difference between the highest and the lowest General Parity Index (GPI) of Liberia?
Your answer should be very brief. 0.44. What is the difference between the highest and the lowest General Parity Index (GPI) in Nigeria?
Provide a short and direct response. 0.44. 